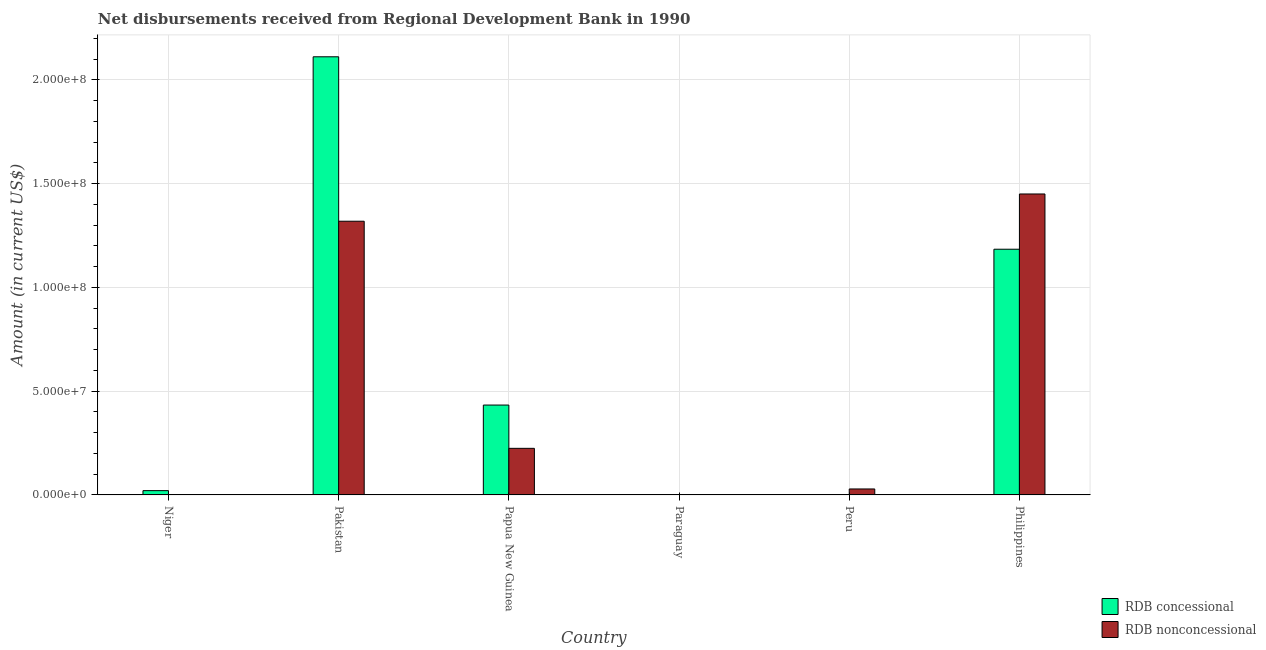Are the number of bars on each tick of the X-axis equal?
Ensure brevity in your answer.  No. How many bars are there on the 5th tick from the right?
Offer a very short reply. 2. What is the label of the 5th group of bars from the left?
Keep it short and to the point. Peru. In how many cases, is the number of bars for a given country not equal to the number of legend labels?
Your answer should be very brief. 3. What is the net concessional disbursements from rdb in Niger?
Give a very brief answer. 2.07e+06. Across all countries, what is the maximum net concessional disbursements from rdb?
Provide a short and direct response. 2.11e+08. Across all countries, what is the minimum net non concessional disbursements from rdb?
Your answer should be very brief. 0. In which country was the net non concessional disbursements from rdb maximum?
Keep it short and to the point. Philippines. What is the total net concessional disbursements from rdb in the graph?
Give a very brief answer. 3.75e+08. What is the difference between the net concessional disbursements from rdb in Papua New Guinea and that in Philippines?
Your answer should be very brief. -7.51e+07. What is the average net concessional disbursements from rdb per country?
Your answer should be compact. 6.25e+07. What is the difference between the net non concessional disbursements from rdb and net concessional disbursements from rdb in Pakistan?
Make the answer very short. -7.92e+07. What is the ratio of the net non concessional disbursements from rdb in Pakistan to that in Peru?
Ensure brevity in your answer.  45.78. What is the difference between the highest and the second highest net non concessional disbursements from rdb?
Provide a succinct answer. 1.31e+07. What is the difference between the highest and the lowest net concessional disbursements from rdb?
Keep it short and to the point. 2.11e+08. How many countries are there in the graph?
Offer a very short reply. 6. Are the values on the major ticks of Y-axis written in scientific E-notation?
Offer a very short reply. Yes. Does the graph contain any zero values?
Make the answer very short. Yes. Does the graph contain grids?
Your answer should be compact. Yes. How many legend labels are there?
Make the answer very short. 2. How are the legend labels stacked?
Your answer should be very brief. Vertical. What is the title of the graph?
Your response must be concise. Net disbursements received from Regional Development Bank in 1990. What is the label or title of the Y-axis?
Give a very brief answer. Amount (in current US$). What is the Amount (in current US$) in RDB concessional in Niger?
Make the answer very short. 2.07e+06. What is the Amount (in current US$) of RDB nonconcessional in Niger?
Make the answer very short. 0. What is the Amount (in current US$) in RDB concessional in Pakistan?
Your answer should be compact. 2.11e+08. What is the Amount (in current US$) of RDB nonconcessional in Pakistan?
Offer a terse response. 1.32e+08. What is the Amount (in current US$) of RDB concessional in Papua New Guinea?
Your response must be concise. 4.33e+07. What is the Amount (in current US$) in RDB nonconcessional in Papua New Guinea?
Your answer should be compact. 2.25e+07. What is the Amount (in current US$) of RDB nonconcessional in Paraguay?
Give a very brief answer. 0. What is the Amount (in current US$) of RDB concessional in Peru?
Your response must be concise. 0. What is the Amount (in current US$) of RDB nonconcessional in Peru?
Offer a very short reply. 2.88e+06. What is the Amount (in current US$) in RDB concessional in Philippines?
Your answer should be very brief. 1.18e+08. What is the Amount (in current US$) in RDB nonconcessional in Philippines?
Give a very brief answer. 1.45e+08. Across all countries, what is the maximum Amount (in current US$) in RDB concessional?
Your response must be concise. 2.11e+08. Across all countries, what is the maximum Amount (in current US$) in RDB nonconcessional?
Offer a terse response. 1.45e+08. Across all countries, what is the minimum Amount (in current US$) in RDB concessional?
Your response must be concise. 0. What is the total Amount (in current US$) of RDB concessional in the graph?
Ensure brevity in your answer.  3.75e+08. What is the total Amount (in current US$) of RDB nonconcessional in the graph?
Ensure brevity in your answer.  3.02e+08. What is the difference between the Amount (in current US$) in RDB concessional in Niger and that in Pakistan?
Provide a short and direct response. -2.09e+08. What is the difference between the Amount (in current US$) of RDB concessional in Niger and that in Papua New Guinea?
Give a very brief answer. -4.12e+07. What is the difference between the Amount (in current US$) of RDB concessional in Niger and that in Philippines?
Offer a terse response. -1.16e+08. What is the difference between the Amount (in current US$) in RDB concessional in Pakistan and that in Papua New Guinea?
Keep it short and to the point. 1.68e+08. What is the difference between the Amount (in current US$) in RDB nonconcessional in Pakistan and that in Papua New Guinea?
Your answer should be very brief. 1.09e+08. What is the difference between the Amount (in current US$) in RDB nonconcessional in Pakistan and that in Peru?
Provide a short and direct response. 1.29e+08. What is the difference between the Amount (in current US$) in RDB concessional in Pakistan and that in Philippines?
Make the answer very short. 9.27e+07. What is the difference between the Amount (in current US$) in RDB nonconcessional in Pakistan and that in Philippines?
Offer a terse response. -1.31e+07. What is the difference between the Amount (in current US$) in RDB nonconcessional in Papua New Guinea and that in Peru?
Offer a very short reply. 1.96e+07. What is the difference between the Amount (in current US$) in RDB concessional in Papua New Guinea and that in Philippines?
Offer a very short reply. -7.51e+07. What is the difference between the Amount (in current US$) in RDB nonconcessional in Papua New Guinea and that in Philippines?
Keep it short and to the point. -1.23e+08. What is the difference between the Amount (in current US$) in RDB nonconcessional in Peru and that in Philippines?
Offer a terse response. -1.42e+08. What is the difference between the Amount (in current US$) in RDB concessional in Niger and the Amount (in current US$) in RDB nonconcessional in Pakistan?
Keep it short and to the point. -1.30e+08. What is the difference between the Amount (in current US$) of RDB concessional in Niger and the Amount (in current US$) of RDB nonconcessional in Papua New Guinea?
Ensure brevity in your answer.  -2.04e+07. What is the difference between the Amount (in current US$) of RDB concessional in Niger and the Amount (in current US$) of RDB nonconcessional in Peru?
Ensure brevity in your answer.  -8.07e+05. What is the difference between the Amount (in current US$) in RDB concessional in Niger and the Amount (in current US$) in RDB nonconcessional in Philippines?
Provide a short and direct response. -1.43e+08. What is the difference between the Amount (in current US$) of RDB concessional in Pakistan and the Amount (in current US$) of RDB nonconcessional in Papua New Guinea?
Ensure brevity in your answer.  1.89e+08. What is the difference between the Amount (in current US$) of RDB concessional in Pakistan and the Amount (in current US$) of RDB nonconcessional in Peru?
Make the answer very short. 2.08e+08. What is the difference between the Amount (in current US$) of RDB concessional in Pakistan and the Amount (in current US$) of RDB nonconcessional in Philippines?
Your answer should be compact. 6.61e+07. What is the difference between the Amount (in current US$) of RDB concessional in Papua New Guinea and the Amount (in current US$) of RDB nonconcessional in Peru?
Ensure brevity in your answer.  4.04e+07. What is the difference between the Amount (in current US$) in RDB concessional in Papua New Guinea and the Amount (in current US$) in RDB nonconcessional in Philippines?
Provide a short and direct response. -1.02e+08. What is the average Amount (in current US$) of RDB concessional per country?
Keep it short and to the point. 6.25e+07. What is the average Amount (in current US$) of RDB nonconcessional per country?
Your answer should be very brief. 5.04e+07. What is the difference between the Amount (in current US$) of RDB concessional and Amount (in current US$) of RDB nonconcessional in Pakistan?
Ensure brevity in your answer.  7.92e+07. What is the difference between the Amount (in current US$) of RDB concessional and Amount (in current US$) of RDB nonconcessional in Papua New Guinea?
Make the answer very short. 2.09e+07. What is the difference between the Amount (in current US$) of RDB concessional and Amount (in current US$) of RDB nonconcessional in Philippines?
Your response must be concise. -2.66e+07. What is the ratio of the Amount (in current US$) in RDB concessional in Niger to that in Pakistan?
Give a very brief answer. 0.01. What is the ratio of the Amount (in current US$) in RDB concessional in Niger to that in Papua New Guinea?
Your answer should be compact. 0.05. What is the ratio of the Amount (in current US$) in RDB concessional in Niger to that in Philippines?
Offer a terse response. 0.02. What is the ratio of the Amount (in current US$) of RDB concessional in Pakistan to that in Papua New Guinea?
Offer a very short reply. 4.87. What is the ratio of the Amount (in current US$) of RDB nonconcessional in Pakistan to that in Papua New Guinea?
Your answer should be compact. 5.87. What is the ratio of the Amount (in current US$) in RDB nonconcessional in Pakistan to that in Peru?
Your response must be concise. 45.78. What is the ratio of the Amount (in current US$) in RDB concessional in Pakistan to that in Philippines?
Keep it short and to the point. 1.78. What is the ratio of the Amount (in current US$) of RDB nonconcessional in Pakistan to that in Philippines?
Your response must be concise. 0.91. What is the ratio of the Amount (in current US$) in RDB nonconcessional in Papua New Guinea to that in Peru?
Offer a terse response. 7.79. What is the ratio of the Amount (in current US$) in RDB concessional in Papua New Guinea to that in Philippines?
Give a very brief answer. 0.37. What is the ratio of the Amount (in current US$) of RDB nonconcessional in Papua New Guinea to that in Philippines?
Ensure brevity in your answer.  0.15. What is the ratio of the Amount (in current US$) of RDB nonconcessional in Peru to that in Philippines?
Keep it short and to the point. 0.02. What is the difference between the highest and the second highest Amount (in current US$) of RDB concessional?
Your answer should be very brief. 9.27e+07. What is the difference between the highest and the second highest Amount (in current US$) in RDB nonconcessional?
Your response must be concise. 1.31e+07. What is the difference between the highest and the lowest Amount (in current US$) in RDB concessional?
Offer a very short reply. 2.11e+08. What is the difference between the highest and the lowest Amount (in current US$) of RDB nonconcessional?
Give a very brief answer. 1.45e+08. 